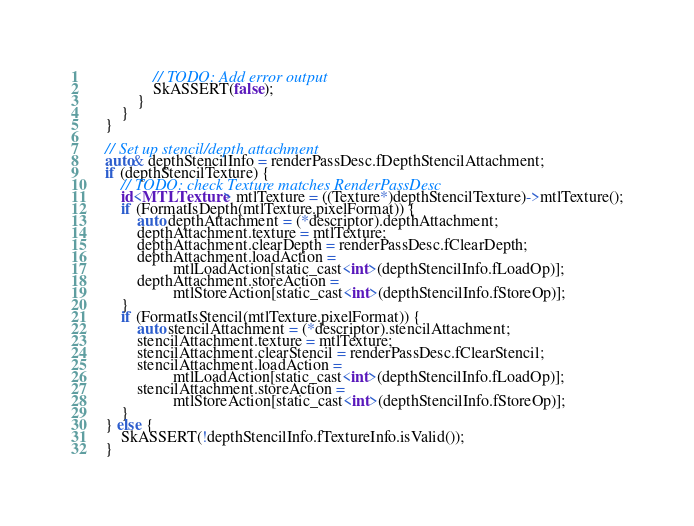<code> <loc_0><loc_0><loc_500><loc_500><_ObjectiveC_>                // TODO: Add error output
                SkASSERT(false);
            }
        }
    }

    // Set up stencil/depth attachment
    auto& depthStencilInfo = renderPassDesc.fDepthStencilAttachment;
    if (depthStencilTexture) {
        // TODO: check Texture matches RenderPassDesc
        id<MTLTexture> mtlTexture = ((Texture*)depthStencilTexture)->mtlTexture();
        if (FormatIsDepth(mtlTexture.pixelFormat)) {
            auto depthAttachment = (*descriptor).depthAttachment;
            depthAttachment.texture = mtlTexture;
            depthAttachment.clearDepth = renderPassDesc.fClearDepth;
            depthAttachment.loadAction =
                     mtlLoadAction[static_cast<int>(depthStencilInfo.fLoadOp)];
            depthAttachment.storeAction =
                     mtlStoreAction[static_cast<int>(depthStencilInfo.fStoreOp)];
        }
        if (FormatIsStencil(mtlTexture.pixelFormat)) {
            auto stencilAttachment = (*descriptor).stencilAttachment;
            stencilAttachment.texture = mtlTexture;
            stencilAttachment.clearStencil = renderPassDesc.fClearStencil;
            stencilAttachment.loadAction =
                     mtlLoadAction[static_cast<int>(depthStencilInfo.fLoadOp)];
            stencilAttachment.storeAction =
                     mtlStoreAction[static_cast<int>(depthStencilInfo.fStoreOp)];
        }
    } else {
        SkASSERT(!depthStencilInfo.fTextureInfo.isValid());
    }
</code> 